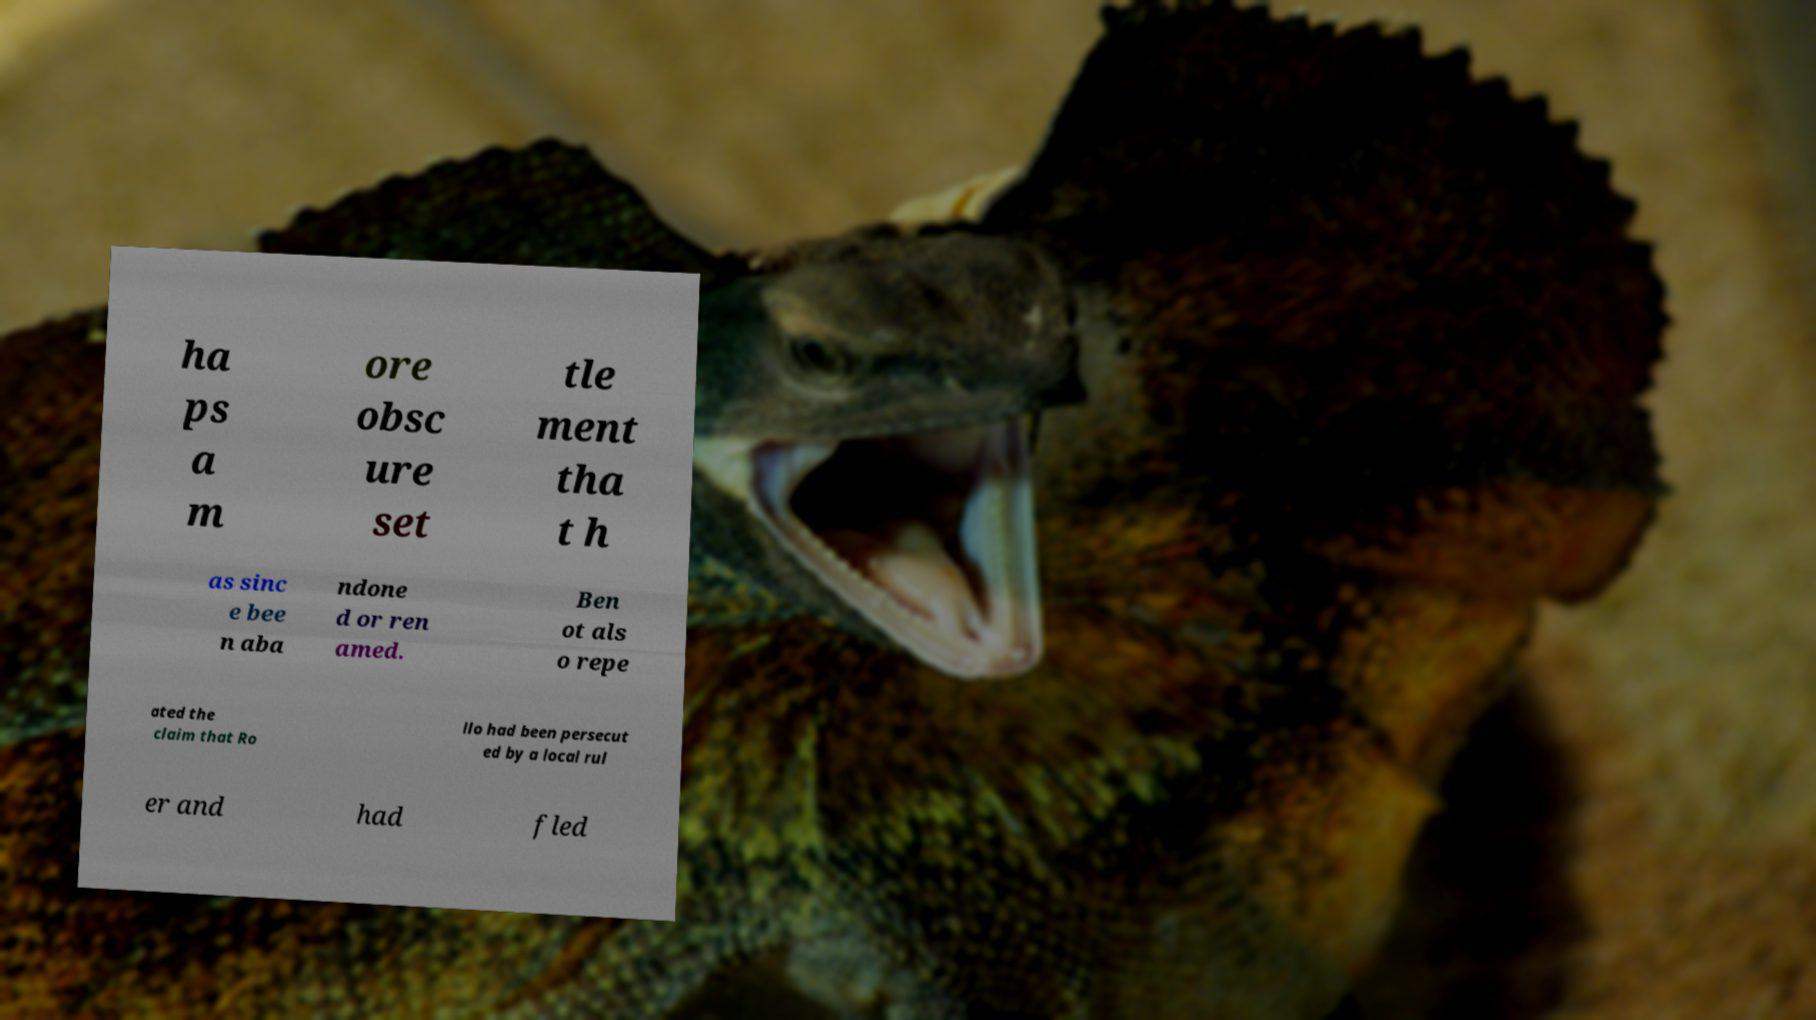I need the written content from this picture converted into text. Can you do that? ha ps a m ore obsc ure set tle ment tha t h as sinc e bee n aba ndone d or ren amed. Ben ot als o repe ated the claim that Ro llo had been persecut ed by a local rul er and had fled 